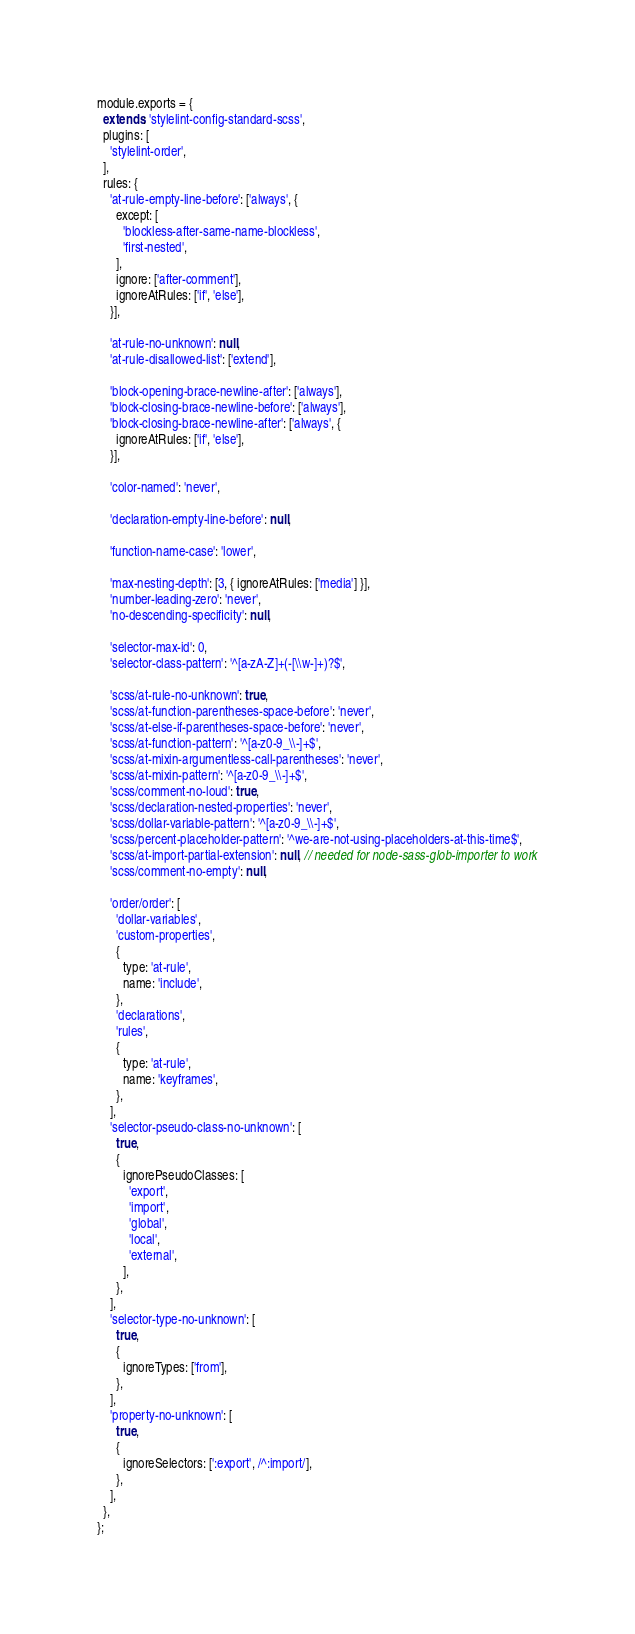<code> <loc_0><loc_0><loc_500><loc_500><_JavaScript_>module.exports = {
  extends: 'stylelint-config-standard-scss',
  plugins: [
    'stylelint-order',
  ],
  rules: {
    'at-rule-empty-line-before': ['always', {
      except: [
        'blockless-after-same-name-blockless',
        'first-nested',
      ],
      ignore: ['after-comment'],
      ignoreAtRules: ['if', 'else'],
    }],

    'at-rule-no-unknown': null,
    'at-rule-disallowed-list': ['extend'],

    'block-opening-brace-newline-after': ['always'],
    'block-closing-brace-newline-before': ['always'],
    'block-closing-brace-newline-after': ['always', {
      ignoreAtRules: ['if', 'else'],
    }],

    'color-named': 'never',

    'declaration-empty-line-before': null,

    'function-name-case': 'lower',

    'max-nesting-depth': [3, { ignoreAtRules: ['media'] }],
    'number-leading-zero': 'never',
    'no-descending-specificity': null,

    'selector-max-id': 0,
    'selector-class-pattern': '^[a-zA-Z]+(-[\\w-]+)?$',

    'scss/at-rule-no-unknown': true,
    'scss/at-function-parentheses-space-before': 'never',
    'scss/at-else-if-parentheses-space-before': 'never',
    'scss/at-function-pattern': '^[a-z0-9_\\-]+$',
    'scss/at-mixin-argumentless-call-parentheses': 'never',
    'scss/at-mixin-pattern': '^[a-z0-9_\\-]+$',
    'scss/comment-no-loud': true,
    'scss/declaration-nested-properties': 'never',
    'scss/dollar-variable-pattern': '^[a-z0-9_\\-]+$',
    'scss/percent-placeholder-pattern': '^we-are-not-using-placeholders-at-this-time$',
    'scss/at-import-partial-extension': null, // needed for node-sass-glob-importer to work
    'scss/comment-no-empty': null,

    'order/order': [
      'dollar-variables',
      'custom-properties',
      {
        type: 'at-rule',
        name: 'include',
      },
      'declarations',
      'rules',
      {
        type: 'at-rule',
        name: 'keyframes',
      },
    ],
    'selector-pseudo-class-no-unknown': [
      true,
      {
        ignorePseudoClasses: [
          'export',
          'import',
          'global',
          'local',
          'external',
        ],
      },
    ],
    'selector-type-no-unknown': [
      true,
      {
        ignoreTypes: ['from'],
      },
    ],
    'property-no-unknown': [
      true,
      {
        ignoreSelectors: [':export', /^:import/],
      },
    ],
  },
};
</code> 